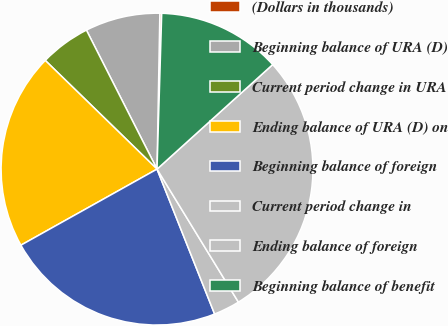Convert chart to OTSL. <chart><loc_0><loc_0><loc_500><loc_500><pie_chart><fcel>(Dollars in thousands)<fcel>Beginning balance of URA (D)<fcel>Current period change in URA<fcel>Ending balance of URA (D) on<fcel>Beginning balance of foreign<fcel>Current period change in<fcel>Ending balance of foreign<fcel>Beginning balance of benefit<nl><fcel>0.19%<fcel>7.77%<fcel>5.24%<fcel>20.39%<fcel>22.91%<fcel>2.72%<fcel>27.96%<fcel>12.82%<nl></chart> 